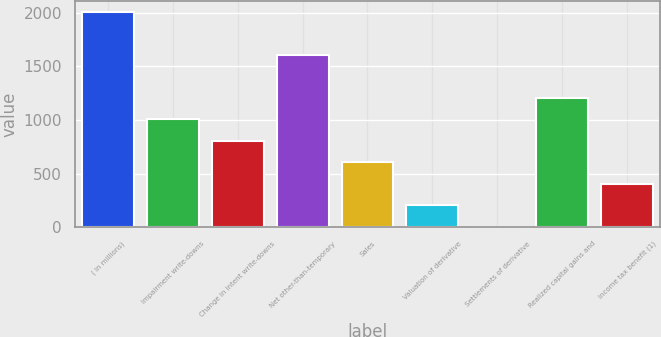Convert chart to OTSL. <chart><loc_0><loc_0><loc_500><loc_500><bar_chart><fcel>( in millions)<fcel>Impairment write-downs<fcel>Change in intent write-downs<fcel>Net other-than-temporary<fcel>Sales<fcel>Valuation of derivative<fcel>Settlements of derivative<fcel>Realized capital gains and<fcel>Income tax benefit (1)<nl><fcel>2007<fcel>1006.5<fcel>806.4<fcel>1606.8<fcel>606.3<fcel>206.1<fcel>6<fcel>1206.6<fcel>406.2<nl></chart> 